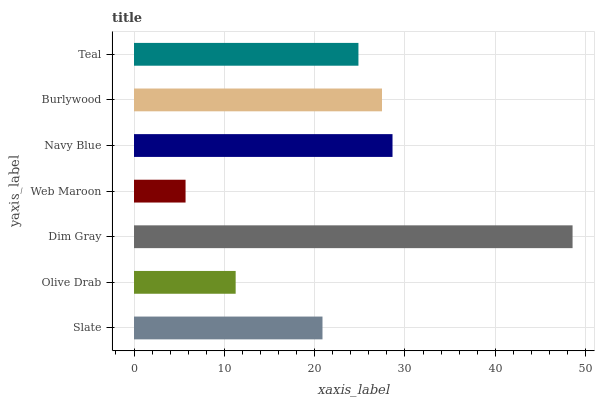Is Web Maroon the minimum?
Answer yes or no. Yes. Is Dim Gray the maximum?
Answer yes or no. Yes. Is Olive Drab the minimum?
Answer yes or no. No. Is Olive Drab the maximum?
Answer yes or no. No. Is Slate greater than Olive Drab?
Answer yes or no. Yes. Is Olive Drab less than Slate?
Answer yes or no. Yes. Is Olive Drab greater than Slate?
Answer yes or no. No. Is Slate less than Olive Drab?
Answer yes or no. No. Is Teal the high median?
Answer yes or no. Yes. Is Teal the low median?
Answer yes or no. Yes. Is Navy Blue the high median?
Answer yes or no. No. Is Web Maroon the low median?
Answer yes or no. No. 